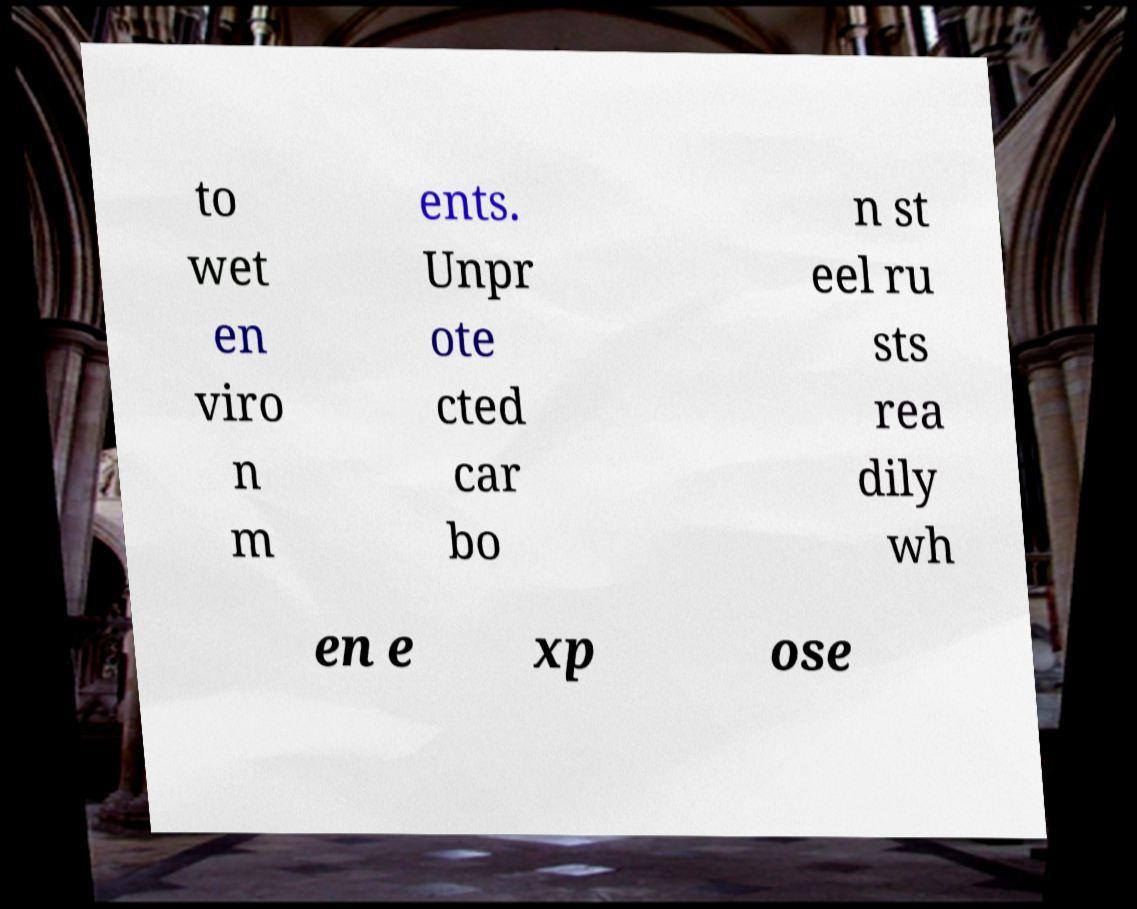I need the written content from this picture converted into text. Can you do that? to wet en viro n m ents. Unpr ote cted car bo n st eel ru sts rea dily wh en e xp ose 